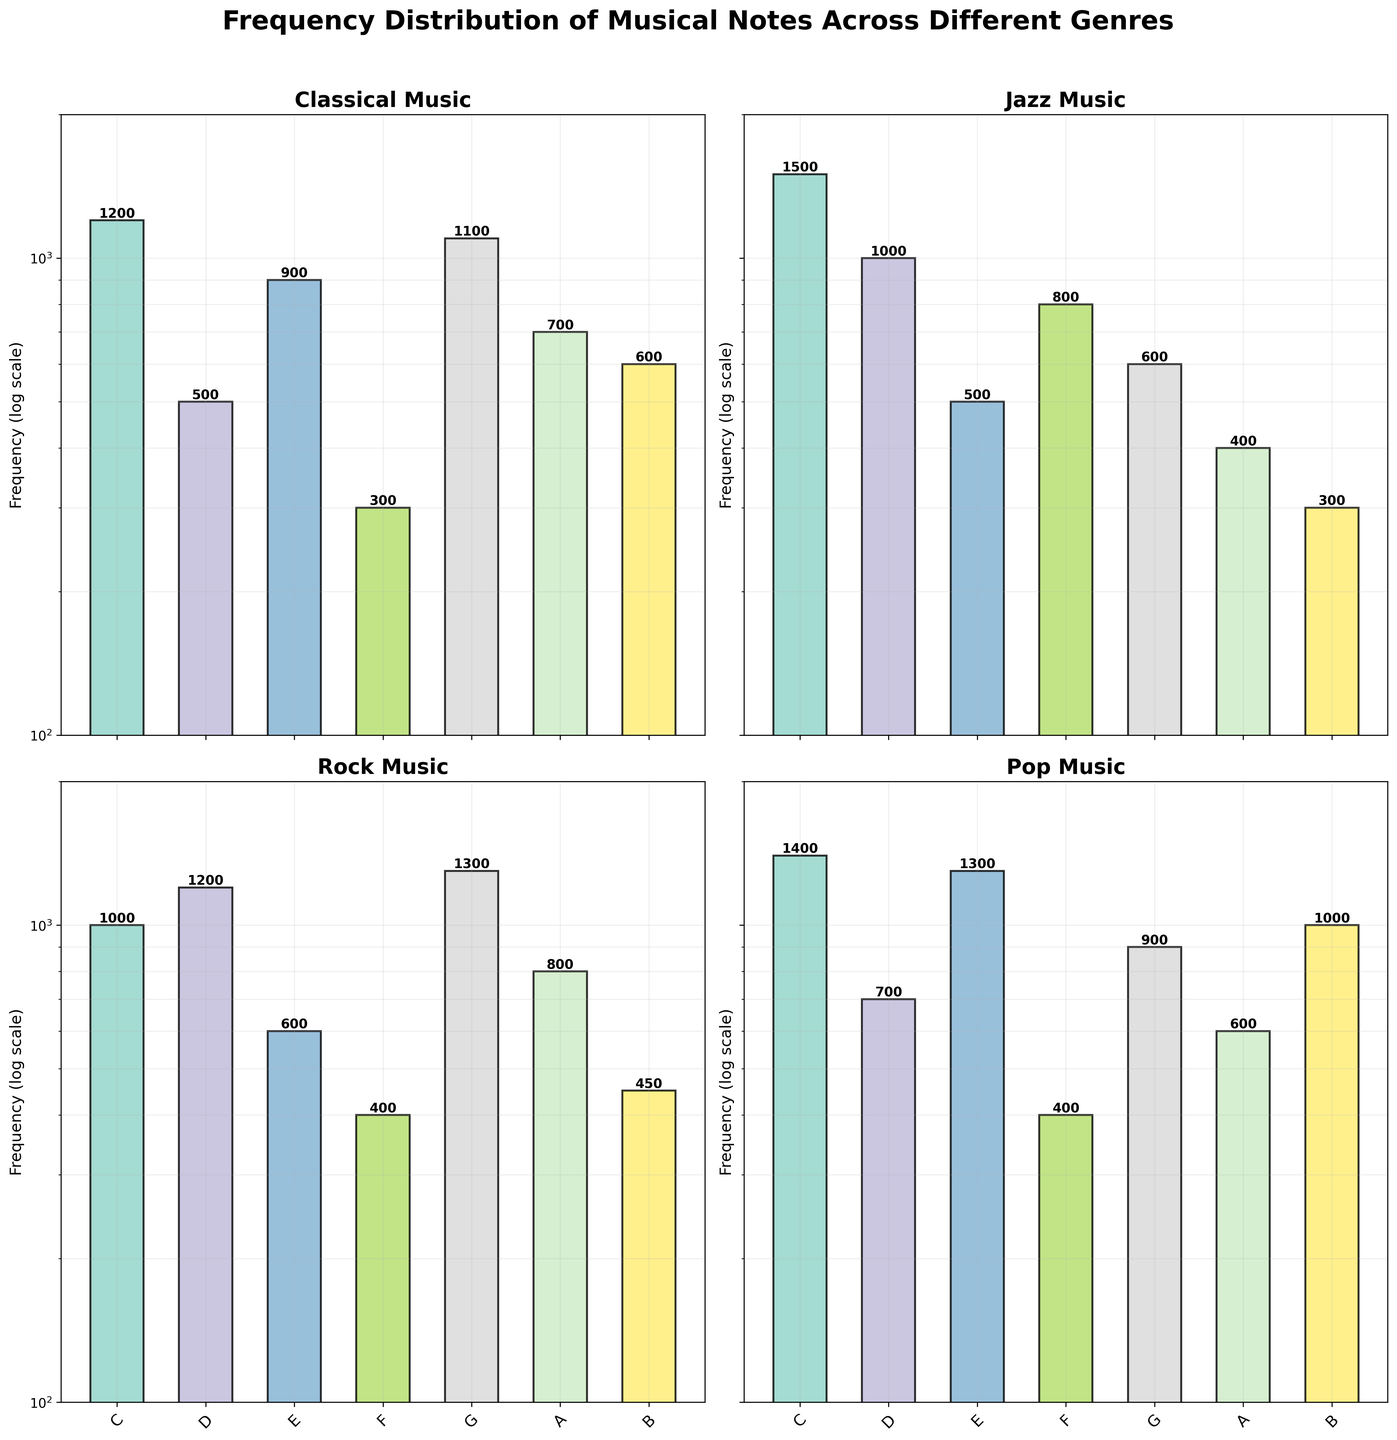what is the title of the figure? The title of the figure is usually at the top of the plot. In this case, it is “Frequency Distribution of Musical Notes Across Different Genres” as mentioned in the code.
Answer: Frequency Distribution of Musical Notes Across Different Genres Which genre has the highest frequency for the note C? Look at the log-scaled y-values for each genre's subplot, and compare the height of the bars corresponding to the note C. Jazz has the highest frequency for the note C, visible as the tallest bar among the genres.
Answer: Jazz What is the range of frequencies shown in the plot on a log scale? The y-axis uses a log scale and the code specifies that the y-axis limits are set between 100 and 2000. This means the frequencies shown in the plot range from 100 to 2000 on a logarithmic scale.
Answer: 100 to 2000 What note has the lowest frequency in Rock music? Examine the subplot for Rock music and identify the bar with the smallest height. The note B has the lowest frequency, shown as the shortest bar in the Rock music subplot.
Answer: B Which genre has the most varied frequency distribution across the notes? To determine variability, compare the spread and fluctuation of bar heights for each genre. Classical music has a more varied pattern with a wide range of frequencies across different notes compared to more consistent distributions in other genres.
Answer: Classical What is the total frequency of notes C, E, and G in Pop music? Look at the heights of the bars for notes C, E, and G in the Pop music subplot and sum their frequencies: C (1400) + E (1300) + G (900) = 3600.
Answer: 3600 Compare the frequency of note A in Classical and Jazz. Which one is higher and by how much? Identify the heights of the bar for note A in Classical (700) and Jazz (400). The Classical frequency is higher, so calculate the difference: 700 - 400 = 300.
Answer: Classical by 300 Is there any note that has the same frequency across two different genres? If so, which note and genres? Compare the heights of the bars for each note across the subplots. Note F has the same frequency (400) in both Rock and Pop music.
Answer: F in Rock and Pop How does the frequency distribution of note D in Rock and Pop compare? Identify the bars representing note D in Rock (1200) and Pop (700). Since 1200 is greater than 700, note D has a higher frequency in Rock compared to Pop.
Answer: Rock is higher Which genre has the lowest frequency for note E, and what is that frequency? Examine the bars for note E across all subplots. Jazz has the lowest frequency for note E, shown by the shortest bar at 500.
Answer: Jazz, 500 